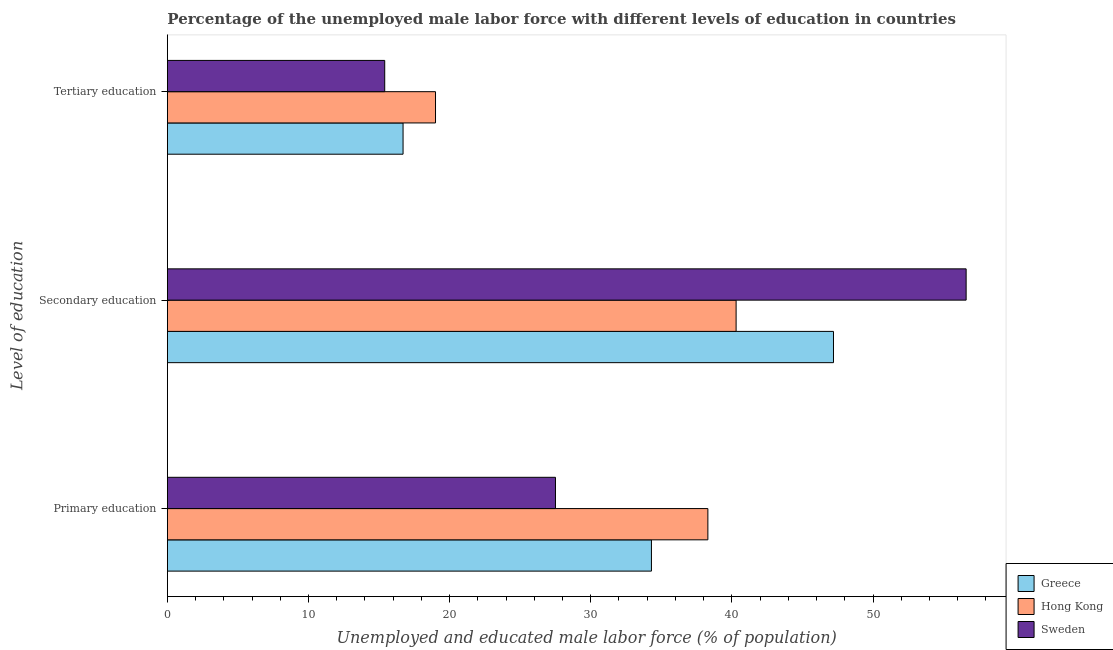How many different coloured bars are there?
Keep it short and to the point. 3. Are the number of bars per tick equal to the number of legend labels?
Keep it short and to the point. Yes. How many bars are there on the 1st tick from the top?
Offer a very short reply. 3. How many bars are there on the 3rd tick from the bottom?
Offer a terse response. 3. What is the label of the 2nd group of bars from the top?
Your answer should be compact. Secondary education. What is the percentage of male labor force who received primary education in Hong Kong?
Keep it short and to the point. 38.3. Across all countries, what is the maximum percentage of male labor force who received primary education?
Offer a very short reply. 38.3. In which country was the percentage of male labor force who received primary education maximum?
Provide a succinct answer. Hong Kong. In which country was the percentage of male labor force who received secondary education minimum?
Keep it short and to the point. Hong Kong. What is the total percentage of male labor force who received primary education in the graph?
Offer a very short reply. 100.1. What is the difference between the percentage of male labor force who received primary education in Sweden and that in Hong Kong?
Provide a short and direct response. -10.8. What is the difference between the percentage of male labor force who received secondary education in Sweden and the percentage of male labor force who received primary education in Hong Kong?
Your answer should be compact. 18.3. What is the average percentage of male labor force who received tertiary education per country?
Offer a very short reply. 17.03. What is the difference between the percentage of male labor force who received secondary education and percentage of male labor force who received tertiary education in Sweden?
Keep it short and to the point. 41.2. What is the ratio of the percentage of male labor force who received tertiary education in Sweden to that in Greece?
Keep it short and to the point. 0.92. Is the percentage of male labor force who received primary education in Greece less than that in Hong Kong?
Provide a succinct answer. Yes. Is the difference between the percentage of male labor force who received primary education in Sweden and Greece greater than the difference between the percentage of male labor force who received tertiary education in Sweden and Greece?
Keep it short and to the point. No. What is the difference between the highest and the second highest percentage of male labor force who received secondary education?
Keep it short and to the point. 9.4. What is the difference between the highest and the lowest percentage of male labor force who received secondary education?
Offer a very short reply. 16.3. In how many countries, is the percentage of male labor force who received primary education greater than the average percentage of male labor force who received primary education taken over all countries?
Your response must be concise. 2. What does the 3rd bar from the top in Secondary education represents?
Your answer should be compact. Greece. What does the 2nd bar from the bottom in Secondary education represents?
Provide a succinct answer. Hong Kong. How many bars are there?
Keep it short and to the point. 9. Are all the bars in the graph horizontal?
Give a very brief answer. Yes. How many countries are there in the graph?
Offer a very short reply. 3. What is the difference between two consecutive major ticks on the X-axis?
Give a very brief answer. 10. How are the legend labels stacked?
Provide a short and direct response. Vertical. What is the title of the graph?
Make the answer very short. Percentage of the unemployed male labor force with different levels of education in countries. What is the label or title of the X-axis?
Offer a terse response. Unemployed and educated male labor force (% of population). What is the label or title of the Y-axis?
Your answer should be very brief. Level of education. What is the Unemployed and educated male labor force (% of population) in Greece in Primary education?
Provide a short and direct response. 34.3. What is the Unemployed and educated male labor force (% of population) in Hong Kong in Primary education?
Provide a succinct answer. 38.3. What is the Unemployed and educated male labor force (% of population) of Greece in Secondary education?
Ensure brevity in your answer.  47.2. What is the Unemployed and educated male labor force (% of population) of Hong Kong in Secondary education?
Your answer should be very brief. 40.3. What is the Unemployed and educated male labor force (% of population) of Sweden in Secondary education?
Provide a short and direct response. 56.6. What is the Unemployed and educated male labor force (% of population) in Greece in Tertiary education?
Make the answer very short. 16.7. What is the Unemployed and educated male labor force (% of population) in Hong Kong in Tertiary education?
Provide a succinct answer. 19. What is the Unemployed and educated male labor force (% of population) of Sweden in Tertiary education?
Your answer should be compact. 15.4. Across all Level of education, what is the maximum Unemployed and educated male labor force (% of population) of Greece?
Ensure brevity in your answer.  47.2. Across all Level of education, what is the maximum Unemployed and educated male labor force (% of population) in Hong Kong?
Offer a very short reply. 40.3. Across all Level of education, what is the maximum Unemployed and educated male labor force (% of population) in Sweden?
Your answer should be very brief. 56.6. Across all Level of education, what is the minimum Unemployed and educated male labor force (% of population) in Greece?
Offer a very short reply. 16.7. Across all Level of education, what is the minimum Unemployed and educated male labor force (% of population) of Hong Kong?
Offer a very short reply. 19. Across all Level of education, what is the minimum Unemployed and educated male labor force (% of population) of Sweden?
Offer a terse response. 15.4. What is the total Unemployed and educated male labor force (% of population) of Greece in the graph?
Offer a terse response. 98.2. What is the total Unemployed and educated male labor force (% of population) in Hong Kong in the graph?
Offer a very short reply. 97.6. What is the total Unemployed and educated male labor force (% of population) in Sweden in the graph?
Your answer should be very brief. 99.5. What is the difference between the Unemployed and educated male labor force (% of population) in Greece in Primary education and that in Secondary education?
Offer a terse response. -12.9. What is the difference between the Unemployed and educated male labor force (% of population) of Hong Kong in Primary education and that in Secondary education?
Give a very brief answer. -2. What is the difference between the Unemployed and educated male labor force (% of population) in Sweden in Primary education and that in Secondary education?
Make the answer very short. -29.1. What is the difference between the Unemployed and educated male labor force (% of population) in Greece in Primary education and that in Tertiary education?
Give a very brief answer. 17.6. What is the difference between the Unemployed and educated male labor force (% of population) of Hong Kong in Primary education and that in Tertiary education?
Give a very brief answer. 19.3. What is the difference between the Unemployed and educated male labor force (% of population) in Sweden in Primary education and that in Tertiary education?
Your answer should be compact. 12.1. What is the difference between the Unemployed and educated male labor force (% of population) in Greece in Secondary education and that in Tertiary education?
Your answer should be compact. 30.5. What is the difference between the Unemployed and educated male labor force (% of population) of Hong Kong in Secondary education and that in Tertiary education?
Ensure brevity in your answer.  21.3. What is the difference between the Unemployed and educated male labor force (% of population) in Sweden in Secondary education and that in Tertiary education?
Offer a terse response. 41.2. What is the difference between the Unemployed and educated male labor force (% of population) of Greece in Primary education and the Unemployed and educated male labor force (% of population) of Sweden in Secondary education?
Your response must be concise. -22.3. What is the difference between the Unemployed and educated male labor force (% of population) of Hong Kong in Primary education and the Unemployed and educated male labor force (% of population) of Sweden in Secondary education?
Keep it short and to the point. -18.3. What is the difference between the Unemployed and educated male labor force (% of population) in Greece in Primary education and the Unemployed and educated male labor force (% of population) in Hong Kong in Tertiary education?
Provide a succinct answer. 15.3. What is the difference between the Unemployed and educated male labor force (% of population) of Hong Kong in Primary education and the Unemployed and educated male labor force (% of population) of Sweden in Tertiary education?
Give a very brief answer. 22.9. What is the difference between the Unemployed and educated male labor force (% of population) of Greece in Secondary education and the Unemployed and educated male labor force (% of population) of Hong Kong in Tertiary education?
Your response must be concise. 28.2. What is the difference between the Unemployed and educated male labor force (% of population) of Greece in Secondary education and the Unemployed and educated male labor force (% of population) of Sweden in Tertiary education?
Your response must be concise. 31.8. What is the difference between the Unemployed and educated male labor force (% of population) of Hong Kong in Secondary education and the Unemployed and educated male labor force (% of population) of Sweden in Tertiary education?
Offer a very short reply. 24.9. What is the average Unemployed and educated male labor force (% of population) in Greece per Level of education?
Offer a terse response. 32.73. What is the average Unemployed and educated male labor force (% of population) of Hong Kong per Level of education?
Provide a succinct answer. 32.53. What is the average Unemployed and educated male labor force (% of population) of Sweden per Level of education?
Provide a short and direct response. 33.17. What is the difference between the Unemployed and educated male labor force (% of population) in Greece and Unemployed and educated male labor force (% of population) in Hong Kong in Primary education?
Your answer should be very brief. -4. What is the difference between the Unemployed and educated male labor force (% of population) in Greece and Unemployed and educated male labor force (% of population) in Sweden in Primary education?
Offer a very short reply. 6.8. What is the difference between the Unemployed and educated male labor force (% of population) in Hong Kong and Unemployed and educated male labor force (% of population) in Sweden in Primary education?
Provide a succinct answer. 10.8. What is the difference between the Unemployed and educated male labor force (% of population) in Hong Kong and Unemployed and educated male labor force (% of population) in Sweden in Secondary education?
Your answer should be compact. -16.3. What is the difference between the Unemployed and educated male labor force (% of population) of Greece and Unemployed and educated male labor force (% of population) of Hong Kong in Tertiary education?
Give a very brief answer. -2.3. What is the difference between the Unemployed and educated male labor force (% of population) of Hong Kong and Unemployed and educated male labor force (% of population) of Sweden in Tertiary education?
Your answer should be very brief. 3.6. What is the ratio of the Unemployed and educated male labor force (% of population) of Greece in Primary education to that in Secondary education?
Your response must be concise. 0.73. What is the ratio of the Unemployed and educated male labor force (% of population) of Hong Kong in Primary education to that in Secondary education?
Your response must be concise. 0.95. What is the ratio of the Unemployed and educated male labor force (% of population) in Sweden in Primary education to that in Secondary education?
Give a very brief answer. 0.49. What is the ratio of the Unemployed and educated male labor force (% of population) in Greece in Primary education to that in Tertiary education?
Your answer should be compact. 2.05. What is the ratio of the Unemployed and educated male labor force (% of population) of Hong Kong in Primary education to that in Tertiary education?
Make the answer very short. 2.02. What is the ratio of the Unemployed and educated male labor force (% of population) of Sweden in Primary education to that in Tertiary education?
Keep it short and to the point. 1.79. What is the ratio of the Unemployed and educated male labor force (% of population) in Greece in Secondary education to that in Tertiary education?
Provide a short and direct response. 2.83. What is the ratio of the Unemployed and educated male labor force (% of population) of Hong Kong in Secondary education to that in Tertiary education?
Your response must be concise. 2.12. What is the ratio of the Unemployed and educated male labor force (% of population) of Sweden in Secondary education to that in Tertiary education?
Give a very brief answer. 3.68. What is the difference between the highest and the second highest Unemployed and educated male labor force (% of population) in Hong Kong?
Your answer should be very brief. 2. What is the difference between the highest and the second highest Unemployed and educated male labor force (% of population) of Sweden?
Your response must be concise. 29.1. What is the difference between the highest and the lowest Unemployed and educated male labor force (% of population) in Greece?
Your answer should be compact. 30.5. What is the difference between the highest and the lowest Unemployed and educated male labor force (% of population) in Hong Kong?
Your response must be concise. 21.3. What is the difference between the highest and the lowest Unemployed and educated male labor force (% of population) of Sweden?
Give a very brief answer. 41.2. 